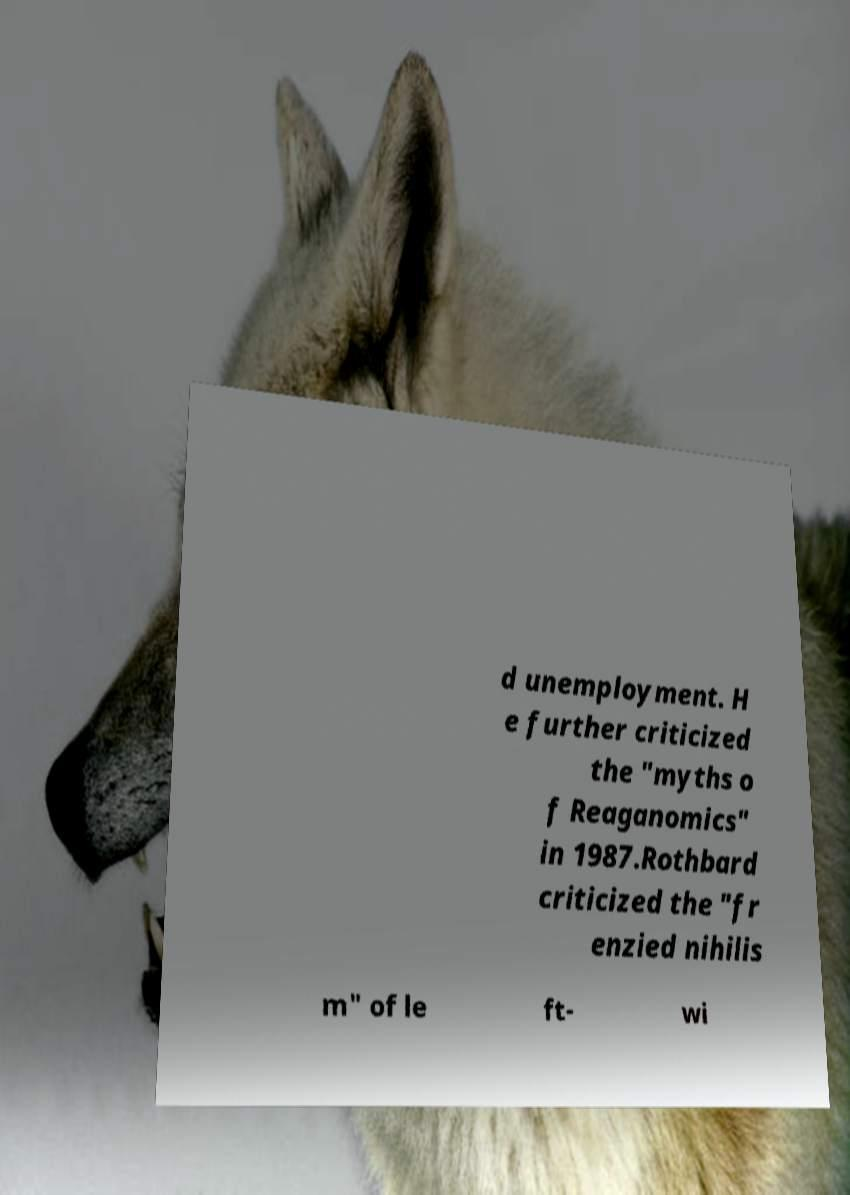Could you extract and type out the text from this image? d unemployment. H e further criticized the "myths o f Reaganomics" in 1987.Rothbard criticized the "fr enzied nihilis m" of le ft- wi 